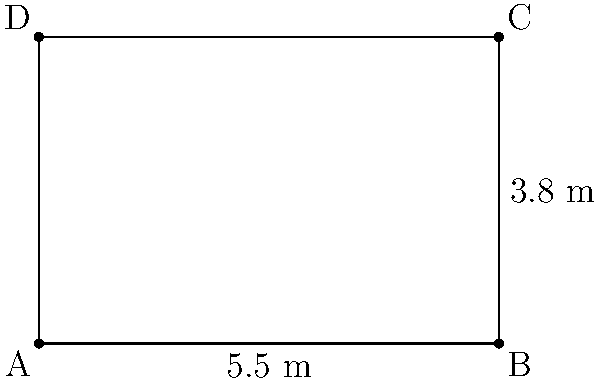As a new intern in the office, you've been asked to calculate the area of a rectangular meeting room. The room's dimensions are 5.5 meters in length and 3.8 meters in width. What is the total area of the room in square meters? To calculate the area of a rectangular room, we need to multiply its length by its width. Let's break it down step-by-step:

1. Identify the given dimensions:
   - Length (l) = 5.5 meters
   - Width (w) = 3.8 meters

2. Use the formula for the area of a rectangle:
   Area (A) = length (l) × width (w)

3. Substitute the values into the formula:
   A = 5.5 m × 3.8 m

4. Perform the multiplication:
   A = 20.9 m²

Therefore, the total area of the rectangular meeting room is 20.9 square meters.
Answer: 20.9 m² 